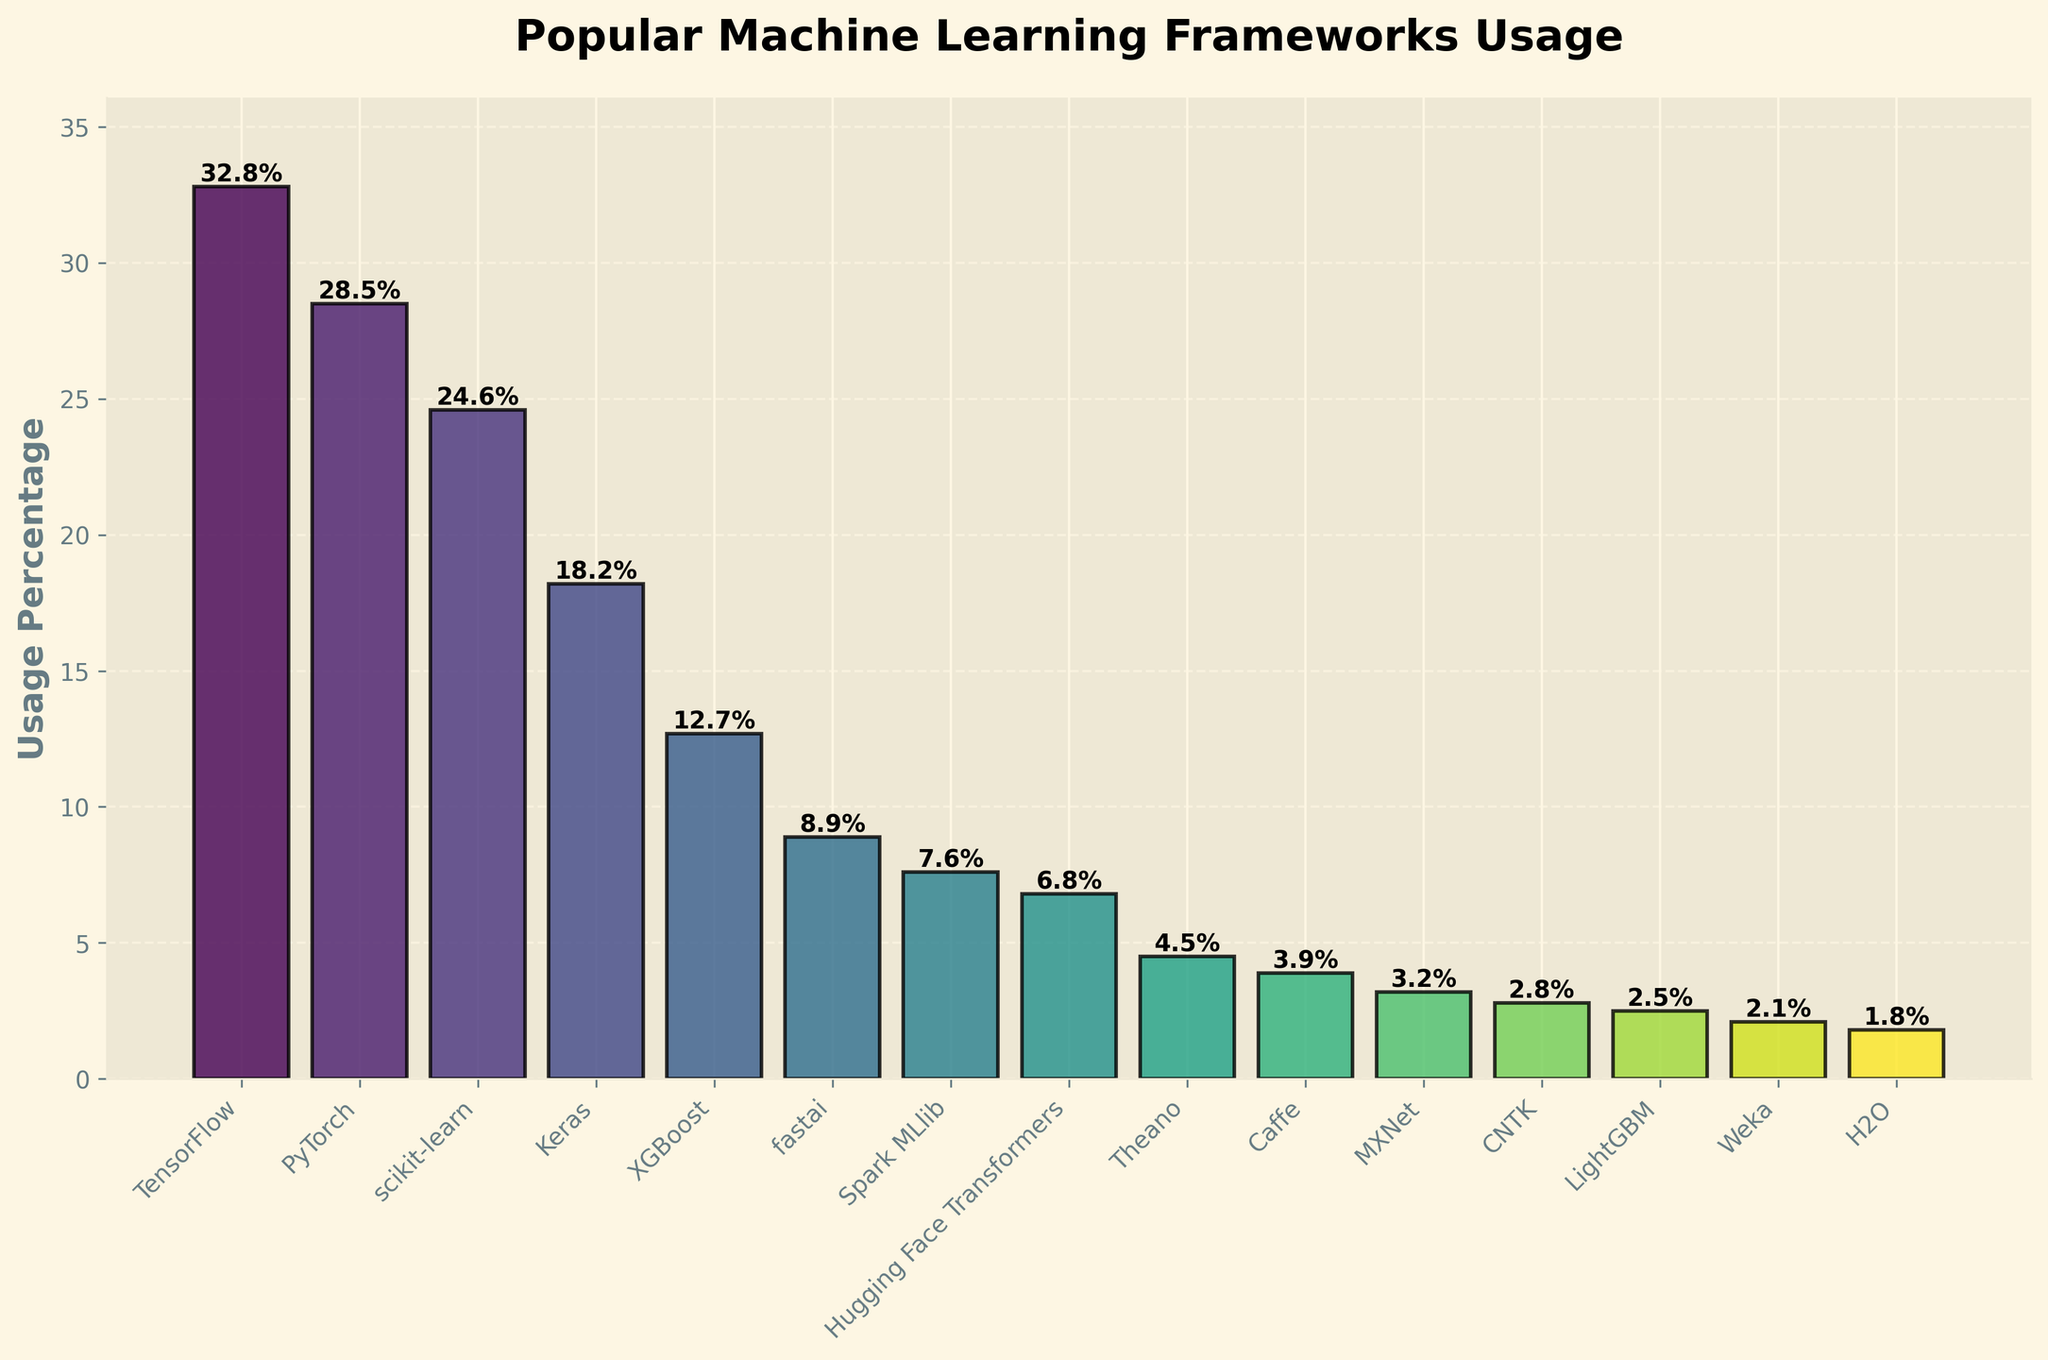What's the usage percentage of the most popular framework? The most popular framework based on the bar heights is TensorFlow. Its data value is shown above its bar.
Answer: 32.8% Which framework has a usage percentage closest to 10%? Check the bar heights around the 10% mark. The closest percentage is for fastai.
Answer: fastai What is the combined usage percentage of the top three frameworks? The top three frameworks are TensorFlow, PyTorch, and scikit-learn. Add their usage percentages: 32.8 + 28.5 + 24.6 = 85.9%
Answer: 85.9% Which framework shows a usage percentage less than 5% but more than 4%? Look for bars between 4% and 5%. Theano fits this description.
Answer: Theano How much higher in usage percentage is TensorFlow compared to MXNet? Subtract the usage percentage of MXNet from TensorFlow: 32.8% - 3.2% = 29.6%
Answer: 29.6% Which framework is represented by the shortest bar? Identify the shortest bar. The shortest bar belongs to H2O.
Answer: H2O Are there any frameworks with an exact usage percentage of 7%? Compare the bar heights with the 7% mark. Spark MLlib is slightly above 7%, but no bar is exactly at 7%.
Answer: No What is the average usage percentage of Keras and fastai? Sum the usage percentages and divide by 2: (18.2 + 8.9) / 2 = 13.55%
Answer: 13.55% Which framework has a higher usage percentage, Hugging Face Transformers or LightGBM? Compare the heights of the two specific bars. Hugging Face Transformers is higher than LightGBM.
Answer: Hugging Face Transformers By how much does the usage percentage of scikit-learn differ from XGBoost? Subtract the usage percentage of XGBoost from scikit-learn: 24.6% - 12.7% = 11.9%
Answer: 11.9% 